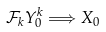<formula> <loc_0><loc_0><loc_500><loc_500>\mathcal { F } _ { k } Y ^ { k } _ { 0 } \Longrightarrow X _ { 0 }</formula> 